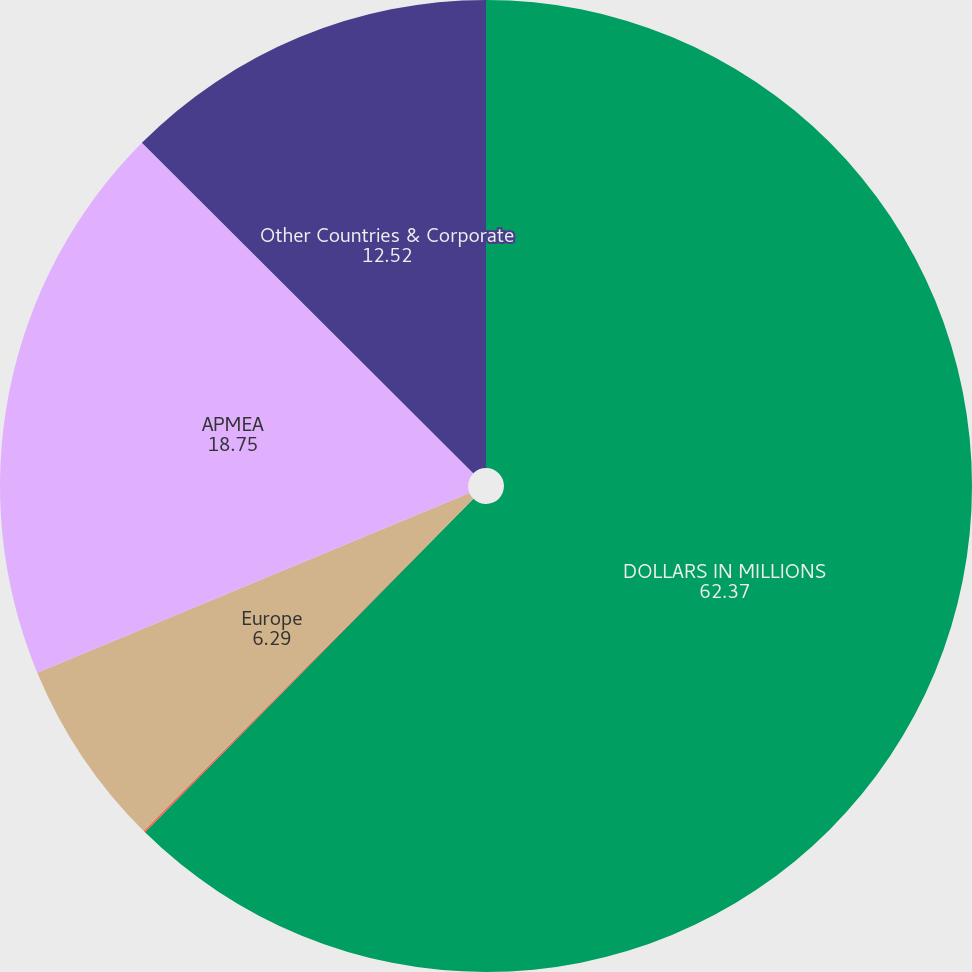Convert chart. <chart><loc_0><loc_0><loc_500><loc_500><pie_chart><fcel>DOLLARS IN MILLIONS<fcel>US<fcel>Europe<fcel>APMEA<fcel>Other Countries & Corporate<nl><fcel>62.37%<fcel>0.06%<fcel>6.29%<fcel>18.75%<fcel>12.52%<nl></chart> 